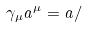<formula> <loc_0><loc_0><loc_500><loc_500>\gamma _ { \mu } a ^ { \mu } = a /</formula> 